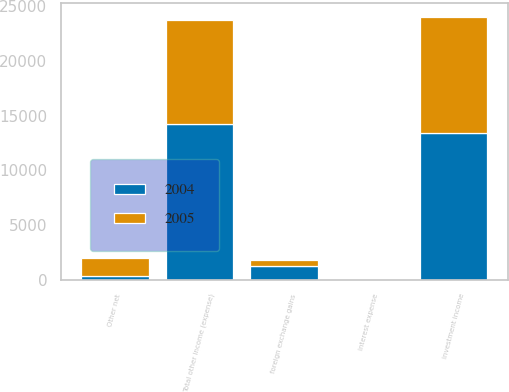Convert chart. <chart><loc_0><loc_0><loc_500><loc_500><stacked_bar_chart><ecel><fcel>investment income<fcel>interest expense<fcel>foreign exchange gains<fcel>Other net<fcel>Total other income (expense)<nl><fcel>2004<fcel>13417<fcel>79<fcel>1286<fcel>370<fcel>14254<nl><fcel>2005<fcel>10628<fcel>44<fcel>485<fcel>1594<fcel>9475<nl></chart> 